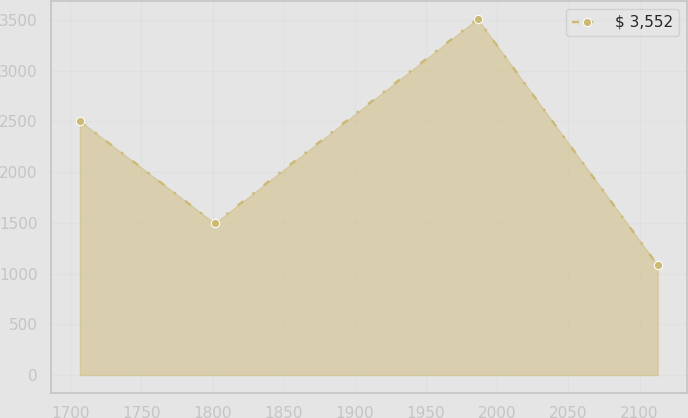<chart> <loc_0><loc_0><loc_500><loc_500><line_chart><ecel><fcel>$ 3,552<nl><fcel>1706.8<fcel>2503.5<nl><fcel>1801.57<fcel>1494.7<nl><fcel>1986.19<fcel>3509.44<nl><fcel>2112.79<fcel>1081.14<nl></chart> 